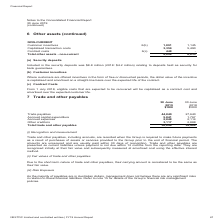According to Nextdc's financial document, How much was the security deposits in 2018? According to the financial document, $4.2 million. The relevant text states: "d in the security deposits was $8.8 million (2018: $4.2 million) relating to deposits held as security for bank guarantees...." Also, What are the types of non-current assets? The document contains multiple relevant values: Contract costs, Customer incentives, Capitalised transaction costs. From the document: "1 1,145 Capitalised transaction costs 3,359 5,490 Contract costs 6(c) 448 - Total other assets - non-current 4,898 6,635 NON-CURRENT Customer incentiv..." Also, What was the total value of non-current assets in 2019? According to the financial document, 4,898 (in thousands). The relevant text states: "costs 6(c) 448 - Total other assets - non-current 4,898 6,635..." Also, can you calculate: What was the percentage change in customer incentives between 2018 and 2019? To answer this question, I need to perform calculations using the financial data. The calculation is: (1,091 - 1,145) / 1,145 , which equals -4.72 (percentage). This is based on the information: "NON-CURRENT Customer incentives 6(b) 1,091 1,145 Capitalised transaction costs 3,359 5,490 Contract costs 6(c) 448 - Total other assets - non-curren NON-CURRENT Customer incentives 6(b) 1,091 1,145 Ca..." The key data points involved are: 1,091, 1,145. Also, can you calculate: What was the percentage change in total other assets that are non-current between 2018 and 2019? To answer this question, I need to perform calculations using the financial data. The calculation is: (6,635 - 4,898) / 4,898 , which equals 35.46 (percentage). This is based on the information: "6(c) 448 - Total other assets - non-current 4,898 6,635 costs 6(c) 448 - Total other assets - non-current 4,898 6,635..." The key data points involved are: 4,898, 6,635. Also, can you calculate: What was the sum of customer incentives and capitalised transaction costs in 2019? Based on the calculation: 1,091 + 3,359 , the result is 4450 (in thousands). This is based on the information: "NON-CURRENT Customer incentives 6(b) 1,091 1,145 Capitalised transaction costs 3,359 5,490 Contract costs 6(c) 448 - Total other assets - non- es 6(b) 1,091 1,145 Capitalised transaction costs 3,359 5..." The key data points involved are: 1,091, 3,359. 